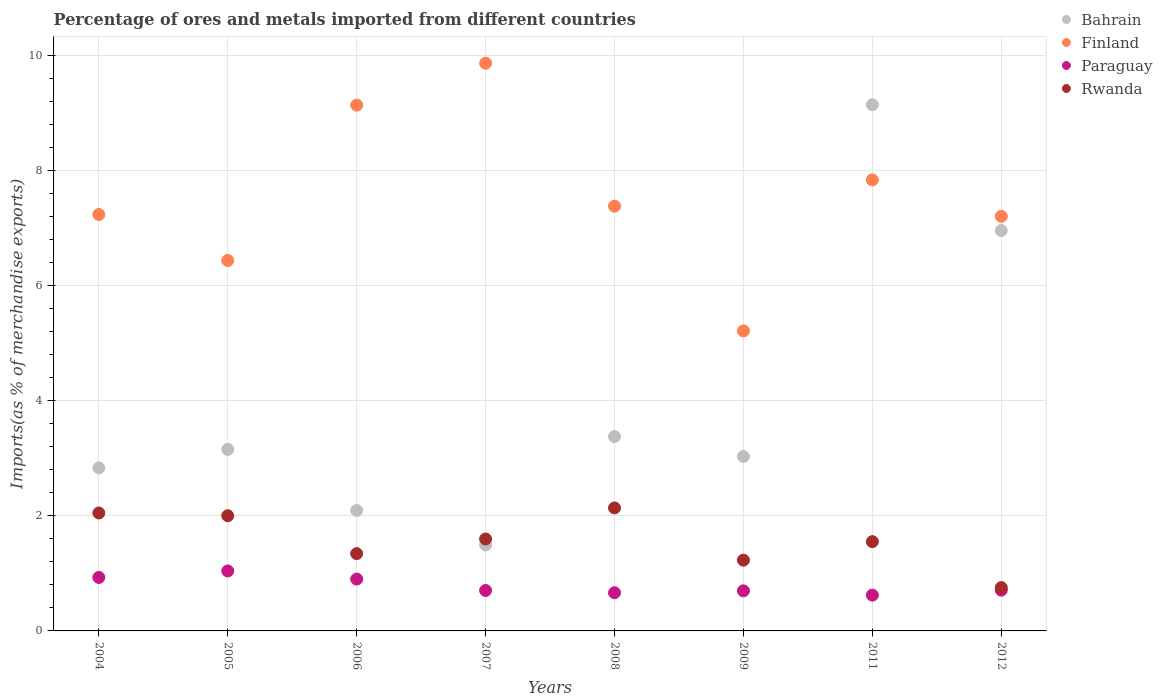What is the percentage of imports to different countries in Bahrain in 2011?
Make the answer very short. 9.14. Across all years, what is the maximum percentage of imports to different countries in Paraguay?
Provide a succinct answer. 1.04. Across all years, what is the minimum percentage of imports to different countries in Paraguay?
Your response must be concise. 0.62. In which year was the percentage of imports to different countries in Paraguay maximum?
Make the answer very short. 2005. In which year was the percentage of imports to different countries in Rwanda minimum?
Provide a short and direct response. 2012. What is the total percentage of imports to different countries in Bahrain in the graph?
Provide a succinct answer. 32.06. What is the difference between the percentage of imports to different countries in Bahrain in 2004 and that in 2012?
Your answer should be very brief. -4.12. What is the difference between the percentage of imports to different countries in Finland in 2006 and the percentage of imports to different countries in Rwanda in 2012?
Your answer should be very brief. 8.38. What is the average percentage of imports to different countries in Bahrain per year?
Your response must be concise. 4.01. In the year 2008, what is the difference between the percentage of imports to different countries in Paraguay and percentage of imports to different countries in Finland?
Your answer should be compact. -6.71. In how many years, is the percentage of imports to different countries in Rwanda greater than 4.4 %?
Offer a very short reply. 0. What is the ratio of the percentage of imports to different countries in Bahrain in 2009 to that in 2011?
Offer a very short reply. 0.33. What is the difference between the highest and the second highest percentage of imports to different countries in Rwanda?
Provide a succinct answer. 0.09. What is the difference between the highest and the lowest percentage of imports to different countries in Rwanda?
Offer a very short reply. 1.38. Is it the case that in every year, the sum of the percentage of imports to different countries in Paraguay and percentage of imports to different countries in Bahrain  is greater than the sum of percentage of imports to different countries in Finland and percentage of imports to different countries in Rwanda?
Make the answer very short. No. Is it the case that in every year, the sum of the percentage of imports to different countries in Paraguay and percentage of imports to different countries in Finland  is greater than the percentage of imports to different countries in Bahrain?
Your answer should be very brief. No. Is the percentage of imports to different countries in Rwanda strictly greater than the percentage of imports to different countries in Paraguay over the years?
Ensure brevity in your answer.  Yes. How many dotlines are there?
Ensure brevity in your answer.  4. How many years are there in the graph?
Make the answer very short. 8. Are the values on the major ticks of Y-axis written in scientific E-notation?
Offer a very short reply. No. Does the graph contain grids?
Ensure brevity in your answer.  Yes. Where does the legend appear in the graph?
Offer a terse response. Top right. What is the title of the graph?
Your answer should be compact. Percentage of ores and metals imported from different countries. What is the label or title of the X-axis?
Offer a very short reply. Years. What is the label or title of the Y-axis?
Give a very brief answer. Imports(as % of merchandise exports). What is the Imports(as % of merchandise exports) of Bahrain in 2004?
Give a very brief answer. 2.83. What is the Imports(as % of merchandise exports) in Finland in 2004?
Offer a very short reply. 7.23. What is the Imports(as % of merchandise exports) in Paraguay in 2004?
Your answer should be very brief. 0.93. What is the Imports(as % of merchandise exports) of Rwanda in 2004?
Offer a terse response. 2.05. What is the Imports(as % of merchandise exports) in Bahrain in 2005?
Provide a short and direct response. 3.15. What is the Imports(as % of merchandise exports) of Finland in 2005?
Provide a short and direct response. 6.43. What is the Imports(as % of merchandise exports) in Paraguay in 2005?
Offer a very short reply. 1.04. What is the Imports(as % of merchandise exports) in Rwanda in 2005?
Your response must be concise. 2. What is the Imports(as % of merchandise exports) of Bahrain in 2006?
Your answer should be very brief. 2.09. What is the Imports(as % of merchandise exports) of Finland in 2006?
Make the answer very short. 9.13. What is the Imports(as % of merchandise exports) of Paraguay in 2006?
Your answer should be compact. 0.9. What is the Imports(as % of merchandise exports) of Rwanda in 2006?
Your answer should be very brief. 1.34. What is the Imports(as % of merchandise exports) of Bahrain in 2007?
Provide a short and direct response. 1.49. What is the Imports(as % of merchandise exports) of Finland in 2007?
Your response must be concise. 9.86. What is the Imports(as % of merchandise exports) in Paraguay in 2007?
Provide a succinct answer. 0.7. What is the Imports(as % of merchandise exports) in Rwanda in 2007?
Your answer should be very brief. 1.6. What is the Imports(as % of merchandise exports) in Bahrain in 2008?
Keep it short and to the point. 3.37. What is the Imports(as % of merchandise exports) in Finland in 2008?
Your answer should be very brief. 7.38. What is the Imports(as % of merchandise exports) in Paraguay in 2008?
Make the answer very short. 0.66. What is the Imports(as % of merchandise exports) in Rwanda in 2008?
Provide a short and direct response. 2.14. What is the Imports(as % of merchandise exports) in Bahrain in 2009?
Ensure brevity in your answer.  3.03. What is the Imports(as % of merchandise exports) in Finland in 2009?
Your answer should be very brief. 5.21. What is the Imports(as % of merchandise exports) in Paraguay in 2009?
Your response must be concise. 0.7. What is the Imports(as % of merchandise exports) in Rwanda in 2009?
Provide a succinct answer. 1.23. What is the Imports(as % of merchandise exports) of Bahrain in 2011?
Give a very brief answer. 9.14. What is the Imports(as % of merchandise exports) in Finland in 2011?
Provide a succinct answer. 7.83. What is the Imports(as % of merchandise exports) in Paraguay in 2011?
Make the answer very short. 0.62. What is the Imports(as % of merchandise exports) of Rwanda in 2011?
Provide a short and direct response. 1.55. What is the Imports(as % of merchandise exports) of Bahrain in 2012?
Offer a very short reply. 6.95. What is the Imports(as % of merchandise exports) in Finland in 2012?
Keep it short and to the point. 7.2. What is the Imports(as % of merchandise exports) of Paraguay in 2012?
Offer a very short reply. 0.71. What is the Imports(as % of merchandise exports) of Rwanda in 2012?
Offer a very short reply. 0.75. Across all years, what is the maximum Imports(as % of merchandise exports) of Bahrain?
Provide a short and direct response. 9.14. Across all years, what is the maximum Imports(as % of merchandise exports) of Finland?
Offer a very short reply. 9.86. Across all years, what is the maximum Imports(as % of merchandise exports) of Paraguay?
Keep it short and to the point. 1.04. Across all years, what is the maximum Imports(as % of merchandise exports) in Rwanda?
Your response must be concise. 2.14. Across all years, what is the minimum Imports(as % of merchandise exports) of Bahrain?
Your response must be concise. 1.49. Across all years, what is the minimum Imports(as % of merchandise exports) of Finland?
Offer a terse response. 5.21. Across all years, what is the minimum Imports(as % of merchandise exports) in Paraguay?
Your answer should be very brief. 0.62. Across all years, what is the minimum Imports(as % of merchandise exports) of Rwanda?
Your answer should be very brief. 0.75. What is the total Imports(as % of merchandise exports) in Bahrain in the graph?
Ensure brevity in your answer.  32.06. What is the total Imports(as % of merchandise exports) in Finland in the graph?
Your answer should be compact. 60.27. What is the total Imports(as % of merchandise exports) of Paraguay in the graph?
Your response must be concise. 6.26. What is the total Imports(as % of merchandise exports) of Rwanda in the graph?
Offer a terse response. 12.66. What is the difference between the Imports(as % of merchandise exports) in Bahrain in 2004 and that in 2005?
Provide a short and direct response. -0.32. What is the difference between the Imports(as % of merchandise exports) in Finland in 2004 and that in 2005?
Provide a succinct answer. 0.8. What is the difference between the Imports(as % of merchandise exports) of Paraguay in 2004 and that in 2005?
Offer a very short reply. -0.11. What is the difference between the Imports(as % of merchandise exports) in Rwanda in 2004 and that in 2005?
Your answer should be very brief. 0.05. What is the difference between the Imports(as % of merchandise exports) of Bahrain in 2004 and that in 2006?
Keep it short and to the point. 0.74. What is the difference between the Imports(as % of merchandise exports) of Finland in 2004 and that in 2006?
Your response must be concise. -1.9. What is the difference between the Imports(as % of merchandise exports) of Paraguay in 2004 and that in 2006?
Your answer should be compact. 0.03. What is the difference between the Imports(as % of merchandise exports) of Rwanda in 2004 and that in 2006?
Your answer should be very brief. 0.71. What is the difference between the Imports(as % of merchandise exports) in Bahrain in 2004 and that in 2007?
Your answer should be compact. 1.34. What is the difference between the Imports(as % of merchandise exports) in Finland in 2004 and that in 2007?
Your response must be concise. -2.63. What is the difference between the Imports(as % of merchandise exports) of Paraguay in 2004 and that in 2007?
Offer a terse response. 0.23. What is the difference between the Imports(as % of merchandise exports) of Rwanda in 2004 and that in 2007?
Your answer should be compact. 0.45. What is the difference between the Imports(as % of merchandise exports) of Bahrain in 2004 and that in 2008?
Your response must be concise. -0.54. What is the difference between the Imports(as % of merchandise exports) of Finland in 2004 and that in 2008?
Your answer should be very brief. -0.14. What is the difference between the Imports(as % of merchandise exports) in Paraguay in 2004 and that in 2008?
Ensure brevity in your answer.  0.27. What is the difference between the Imports(as % of merchandise exports) in Rwanda in 2004 and that in 2008?
Ensure brevity in your answer.  -0.09. What is the difference between the Imports(as % of merchandise exports) in Bahrain in 2004 and that in 2009?
Give a very brief answer. -0.2. What is the difference between the Imports(as % of merchandise exports) in Finland in 2004 and that in 2009?
Keep it short and to the point. 2.02. What is the difference between the Imports(as % of merchandise exports) in Paraguay in 2004 and that in 2009?
Your response must be concise. 0.23. What is the difference between the Imports(as % of merchandise exports) of Rwanda in 2004 and that in 2009?
Keep it short and to the point. 0.82. What is the difference between the Imports(as % of merchandise exports) in Bahrain in 2004 and that in 2011?
Offer a terse response. -6.31. What is the difference between the Imports(as % of merchandise exports) of Finland in 2004 and that in 2011?
Your answer should be compact. -0.6. What is the difference between the Imports(as % of merchandise exports) in Paraguay in 2004 and that in 2011?
Keep it short and to the point. 0.31. What is the difference between the Imports(as % of merchandise exports) in Rwanda in 2004 and that in 2011?
Provide a succinct answer. 0.5. What is the difference between the Imports(as % of merchandise exports) of Bahrain in 2004 and that in 2012?
Make the answer very short. -4.12. What is the difference between the Imports(as % of merchandise exports) in Finland in 2004 and that in 2012?
Offer a very short reply. 0.03. What is the difference between the Imports(as % of merchandise exports) of Paraguay in 2004 and that in 2012?
Your answer should be compact. 0.22. What is the difference between the Imports(as % of merchandise exports) of Rwanda in 2004 and that in 2012?
Offer a terse response. 1.3. What is the difference between the Imports(as % of merchandise exports) of Bahrain in 2005 and that in 2006?
Keep it short and to the point. 1.06. What is the difference between the Imports(as % of merchandise exports) in Finland in 2005 and that in 2006?
Provide a short and direct response. -2.7. What is the difference between the Imports(as % of merchandise exports) in Paraguay in 2005 and that in 2006?
Ensure brevity in your answer.  0.14. What is the difference between the Imports(as % of merchandise exports) in Rwanda in 2005 and that in 2006?
Your answer should be very brief. 0.66. What is the difference between the Imports(as % of merchandise exports) of Bahrain in 2005 and that in 2007?
Provide a short and direct response. 1.66. What is the difference between the Imports(as % of merchandise exports) of Finland in 2005 and that in 2007?
Keep it short and to the point. -3.43. What is the difference between the Imports(as % of merchandise exports) of Paraguay in 2005 and that in 2007?
Your answer should be compact. 0.34. What is the difference between the Imports(as % of merchandise exports) of Rwanda in 2005 and that in 2007?
Give a very brief answer. 0.4. What is the difference between the Imports(as % of merchandise exports) of Bahrain in 2005 and that in 2008?
Your answer should be very brief. -0.22. What is the difference between the Imports(as % of merchandise exports) of Finland in 2005 and that in 2008?
Offer a very short reply. -0.94. What is the difference between the Imports(as % of merchandise exports) of Paraguay in 2005 and that in 2008?
Your response must be concise. 0.38. What is the difference between the Imports(as % of merchandise exports) of Rwanda in 2005 and that in 2008?
Your response must be concise. -0.14. What is the difference between the Imports(as % of merchandise exports) of Bahrain in 2005 and that in 2009?
Your response must be concise. 0.12. What is the difference between the Imports(as % of merchandise exports) in Finland in 2005 and that in 2009?
Keep it short and to the point. 1.22. What is the difference between the Imports(as % of merchandise exports) of Paraguay in 2005 and that in 2009?
Offer a very short reply. 0.34. What is the difference between the Imports(as % of merchandise exports) in Rwanda in 2005 and that in 2009?
Make the answer very short. 0.77. What is the difference between the Imports(as % of merchandise exports) of Bahrain in 2005 and that in 2011?
Make the answer very short. -5.99. What is the difference between the Imports(as % of merchandise exports) of Finland in 2005 and that in 2011?
Ensure brevity in your answer.  -1.4. What is the difference between the Imports(as % of merchandise exports) of Paraguay in 2005 and that in 2011?
Your answer should be compact. 0.42. What is the difference between the Imports(as % of merchandise exports) of Rwanda in 2005 and that in 2011?
Your answer should be very brief. 0.45. What is the difference between the Imports(as % of merchandise exports) in Bahrain in 2005 and that in 2012?
Offer a very short reply. -3.8. What is the difference between the Imports(as % of merchandise exports) of Finland in 2005 and that in 2012?
Make the answer very short. -0.77. What is the difference between the Imports(as % of merchandise exports) in Paraguay in 2005 and that in 2012?
Provide a succinct answer. 0.33. What is the difference between the Imports(as % of merchandise exports) of Rwanda in 2005 and that in 2012?
Provide a short and direct response. 1.25. What is the difference between the Imports(as % of merchandise exports) in Bahrain in 2006 and that in 2007?
Keep it short and to the point. 0.6. What is the difference between the Imports(as % of merchandise exports) in Finland in 2006 and that in 2007?
Your answer should be compact. -0.73. What is the difference between the Imports(as % of merchandise exports) in Paraguay in 2006 and that in 2007?
Offer a very short reply. 0.2. What is the difference between the Imports(as % of merchandise exports) of Rwanda in 2006 and that in 2007?
Offer a terse response. -0.25. What is the difference between the Imports(as % of merchandise exports) in Bahrain in 2006 and that in 2008?
Ensure brevity in your answer.  -1.28. What is the difference between the Imports(as % of merchandise exports) of Finland in 2006 and that in 2008?
Offer a terse response. 1.75. What is the difference between the Imports(as % of merchandise exports) in Paraguay in 2006 and that in 2008?
Your answer should be compact. 0.24. What is the difference between the Imports(as % of merchandise exports) in Rwanda in 2006 and that in 2008?
Give a very brief answer. -0.79. What is the difference between the Imports(as % of merchandise exports) of Bahrain in 2006 and that in 2009?
Your answer should be very brief. -0.94. What is the difference between the Imports(as % of merchandise exports) in Finland in 2006 and that in 2009?
Your answer should be compact. 3.92. What is the difference between the Imports(as % of merchandise exports) of Paraguay in 2006 and that in 2009?
Provide a succinct answer. 0.2. What is the difference between the Imports(as % of merchandise exports) in Rwanda in 2006 and that in 2009?
Your answer should be compact. 0.11. What is the difference between the Imports(as % of merchandise exports) of Bahrain in 2006 and that in 2011?
Offer a very short reply. -7.05. What is the difference between the Imports(as % of merchandise exports) of Finland in 2006 and that in 2011?
Make the answer very short. 1.3. What is the difference between the Imports(as % of merchandise exports) in Paraguay in 2006 and that in 2011?
Provide a short and direct response. 0.28. What is the difference between the Imports(as % of merchandise exports) in Rwanda in 2006 and that in 2011?
Give a very brief answer. -0.21. What is the difference between the Imports(as % of merchandise exports) of Bahrain in 2006 and that in 2012?
Your answer should be very brief. -4.86. What is the difference between the Imports(as % of merchandise exports) of Finland in 2006 and that in 2012?
Offer a terse response. 1.93. What is the difference between the Imports(as % of merchandise exports) in Paraguay in 2006 and that in 2012?
Your answer should be very brief. 0.19. What is the difference between the Imports(as % of merchandise exports) of Rwanda in 2006 and that in 2012?
Keep it short and to the point. 0.59. What is the difference between the Imports(as % of merchandise exports) of Bahrain in 2007 and that in 2008?
Make the answer very short. -1.88. What is the difference between the Imports(as % of merchandise exports) of Finland in 2007 and that in 2008?
Keep it short and to the point. 2.48. What is the difference between the Imports(as % of merchandise exports) in Paraguay in 2007 and that in 2008?
Your response must be concise. 0.04. What is the difference between the Imports(as % of merchandise exports) of Rwanda in 2007 and that in 2008?
Make the answer very short. -0.54. What is the difference between the Imports(as % of merchandise exports) of Bahrain in 2007 and that in 2009?
Your response must be concise. -1.54. What is the difference between the Imports(as % of merchandise exports) of Finland in 2007 and that in 2009?
Make the answer very short. 4.65. What is the difference between the Imports(as % of merchandise exports) in Paraguay in 2007 and that in 2009?
Make the answer very short. 0.01. What is the difference between the Imports(as % of merchandise exports) of Rwanda in 2007 and that in 2009?
Give a very brief answer. 0.37. What is the difference between the Imports(as % of merchandise exports) of Bahrain in 2007 and that in 2011?
Offer a terse response. -7.65. What is the difference between the Imports(as % of merchandise exports) in Finland in 2007 and that in 2011?
Your answer should be compact. 2.03. What is the difference between the Imports(as % of merchandise exports) of Paraguay in 2007 and that in 2011?
Provide a succinct answer. 0.08. What is the difference between the Imports(as % of merchandise exports) of Rwanda in 2007 and that in 2011?
Offer a very short reply. 0.05. What is the difference between the Imports(as % of merchandise exports) in Bahrain in 2007 and that in 2012?
Make the answer very short. -5.46. What is the difference between the Imports(as % of merchandise exports) of Finland in 2007 and that in 2012?
Provide a short and direct response. 2.66. What is the difference between the Imports(as % of merchandise exports) of Paraguay in 2007 and that in 2012?
Ensure brevity in your answer.  -0.01. What is the difference between the Imports(as % of merchandise exports) in Rwanda in 2007 and that in 2012?
Keep it short and to the point. 0.84. What is the difference between the Imports(as % of merchandise exports) in Bahrain in 2008 and that in 2009?
Offer a terse response. 0.34. What is the difference between the Imports(as % of merchandise exports) in Finland in 2008 and that in 2009?
Your answer should be very brief. 2.17. What is the difference between the Imports(as % of merchandise exports) of Paraguay in 2008 and that in 2009?
Your answer should be very brief. -0.03. What is the difference between the Imports(as % of merchandise exports) of Rwanda in 2008 and that in 2009?
Keep it short and to the point. 0.91. What is the difference between the Imports(as % of merchandise exports) of Bahrain in 2008 and that in 2011?
Provide a succinct answer. -5.76. What is the difference between the Imports(as % of merchandise exports) of Finland in 2008 and that in 2011?
Your answer should be compact. -0.46. What is the difference between the Imports(as % of merchandise exports) of Paraguay in 2008 and that in 2011?
Give a very brief answer. 0.04. What is the difference between the Imports(as % of merchandise exports) in Rwanda in 2008 and that in 2011?
Offer a very short reply. 0.59. What is the difference between the Imports(as % of merchandise exports) in Bahrain in 2008 and that in 2012?
Your answer should be compact. -3.58. What is the difference between the Imports(as % of merchandise exports) in Finland in 2008 and that in 2012?
Provide a succinct answer. 0.18. What is the difference between the Imports(as % of merchandise exports) in Paraguay in 2008 and that in 2012?
Give a very brief answer. -0.04. What is the difference between the Imports(as % of merchandise exports) in Rwanda in 2008 and that in 2012?
Ensure brevity in your answer.  1.38. What is the difference between the Imports(as % of merchandise exports) of Bahrain in 2009 and that in 2011?
Offer a very short reply. -6.11. What is the difference between the Imports(as % of merchandise exports) in Finland in 2009 and that in 2011?
Make the answer very short. -2.62. What is the difference between the Imports(as % of merchandise exports) in Paraguay in 2009 and that in 2011?
Provide a short and direct response. 0.07. What is the difference between the Imports(as % of merchandise exports) in Rwanda in 2009 and that in 2011?
Keep it short and to the point. -0.32. What is the difference between the Imports(as % of merchandise exports) of Bahrain in 2009 and that in 2012?
Your answer should be very brief. -3.92. What is the difference between the Imports(as % of merchandise exports) of Finland in 2009 and that in 2012?
Make the answer very short. -1.99. What is the difference between the Imports(as % of merchandise exports) of Paraguay in 2009 and that in 2012?
Ensure brevity in your answer.  -0.01. What is the difference between the Imports(as % of merchandise exports) in Rwanda in 2009 and that in 2012?
Your answer should be very brief. 0.48. What is the difference between the Imports(as % of merchandise exports) of Bahrain in 2011 and that in 2012?
Offer a terse response. 2.19. What is the difference between the Imports(as % of merchandise exports) of Finland in 2011 and that in 2012?
Offer a terse response. 0.63. What is the difference between the Imports(as % of merchandise exports) of Paraguay in 2011 and that in 2012?
Offer a terse response. -0.09. What is the difference between the Imports(as % of merchandise exports) in Rwanda in 2011 and that in 2012?
Offer a very short reply. 0.8. What is the difference between the Imports(as % of merchandise exports) in Bahrain in 2004 and the Imports(as % of merchandise exports) in Finland in 2005?
Your response must be concise. -3.6. What is the difference between the Imports(as % of merchandise exports) of Bahrain in 2004 and the Imports(as % of merchandise exports) of Paraguay in 2005?
Offer a terse response. 1.79. What is the difference between the Imports(as % of merchandise exports) of Bahrain in 2004 and the Imports(as % of merchandise exports) of Rwanda in 2005?
Keep it short and to the point. 0.83. What is the difference between the Imports(as % of merchandise exports) of Finland in 2004 and the Imports(as % of merchandise exports) of Paraguay in 2005?
Offer a terse response. 6.19. What is the difference between the Imports(as % of merchandise exports) in Finland in 2004 and the Imports(as % of merchandise exports) in Rwanda in 2005?
Provide a succinct answer. 5.23. What is the difference between the Imports(as % of merchandise exports) of Paraguay in 2004 and the Imports(as % of merchandise exports) of Rwanda in 2005?
Offer a very short reply. -1.07. What is the difference between the Imports(as % of merchandise exports) of Bahrain in 2004 and the Imports(as % of merchandise exports) of Finland in 2006?
Ensure brevity in your answer.  -6.3. What is the difference between the Imports(as % of merchandise exports) in Bahrain in 2004 and the Imports(as % of merchandise exports) in Paraguay in 2006?
Offer a very short reply. 1.93. What is the difference between the Imports(as % of merchandise exports) of Bahrain in 2004 and the Imports(as % of merchandise exports) of Rwanda in 2006?
Your answer should be very brief. 1.49. What is the difference between the Imports(as % of merchandise exports) in Finland in 2004 and the Imports(as % of merchandise exports) in Paraguay in 2006?
Ensure brevity in your answer.  6.33. What is the difference between the Imports(as % of merchandise exports) of Finland in 2004 and the Imports(as % of merchandise exports) of Rwanda in 2006?
Offer a terse response. 5.89. What is the difference between the Imports(as % of merchandise exports) in Paraguay in 2004 and the Imports(as % of merchandise exports) in Rwanda in 2006?
Your answer should be very brief. -0.41. What is the difference between the Imports(as % of merchandise exports) in Bahrain in 2004 and the Imports(as % of merchandise exports) in Finland in 2007?
Provide a succinct answer. -7.03. What is the difference between the Imports(as % of merchandise exports) of Bahrain in 2004 and the Imports(as % of merchandise exports) of Paraguay in 2007?
Your answer should be very brief. 2.13. What is the difference between the Imports(as % of merchandise exports) of Bahrain in 2004 and the Imports(as % of merchandise exports) of Rwanda in 2007?
Make the answer very short. 1.23. What is the difference between the Imports(as % of merchandise exports) of Finland in 2004 and the Imports(as % of merchandise exports) of Paraguay in 2007?
Offer a terse response. 6.53. What is the difference between the Imports(as % of merchandise exports) of Finland in 2004 and the Imports(as % of merchandise exports) of Rwanda in 2007?
Offer a very short reply. 5.64. What is the difference between the Imports(as % of merchandise exports) in Paraguay in 2004 and the Imports(as % of merchandise exports) in Rwanda in 2007?
Keep it short and to the point. -0.67. What is the difference between the Imports(as % of merchandise exports) of Bahrain in 2004 and the Imports(as % of merchandise exports) of Finland in 2008?
Provide a succinct answer. -4.55. What is the difference between the Imports(as % of merchandise exports) of Bahrain in 2004 and the Imports(as % of merchandise exports) of Paraguay in 2008?
Your response must be concise. 2.17. What is the difference between the Imports(as % of merchandise exports) of Bahrain in 2004 and the Imports(as % of merchandise exports) of Rwanda in 2008?
Offer a very short reply. 0.69. What is the difference between the Imports(as % of merchandise exports) of Finland in 2004 and the Imports(as % of merchandise exports) of Paraguay in 2008?
Your answer should be very brief. 6.57. What is the difference between the Imports(as % of merchandise exports) in Finland in 2004 and the Imports(as % of merchandise exports) in Rwanda in 2008?
Ensure brevity in your answer.  5.1. What is the difference between the Imports(as % of merchandise exports) in Paraguay in 2004 and the Imports(as % of merchandise exports) in Rwanda in 2008?
Keep it short and to the point. -1.21. What is the difference between the Imports(as % of merchandise exports) of Bahrain in 2004 and the Imports(as % of merchandise exports) of Finland in 2009?
Your answer should be very brief. -2.38. What is the difference between the Imports(as % of merchandise exports) in Bahrain in 2004 and the Imports(as % of merchandise exports) in Paraguay in 2009?
Your answer should be very brief. 2.13. What is the difference between the Imports(as % of merchandise exports) in Bahrain in 2004 and the Imports(as % of merchandise exports) in Rwanda in 2009?
Ensure brevity in your answer.  1.6. What is the difference between the Imports(as % of merchandise exports) in Finland in 2004 and the Imports(as % of merchandise exports) in Paraguay in 2009?
Provide a succinct answer. 6.54. What is the difference between the Imports(as % of merchandise exports) of Finland in 2004 and the Imports(as % of merchandise exports) of Rwanda in 2009?
Make the answer very short. 6. What is the difference between the Imports(as % of merchandise exports) of Paraguay in 2004 and the Imports(as % of merchandise exports) of Rwanda in 2009?
Your answer should be compact. -0.3. What is the difference between the Imports(as % of merchandise exports) of Bahrain in 2004 and the Imports(as % of merchandise exports) of Finland in 2011?
Your answer should be very brief. -5. What is the difference between the Imports(as % of merchandise exports) of Bahrain in 2004 and the Imports(as % of merchandise exports) of Paraguay in 2011?
Provide a succinct answer. 2.21. What is the difference between the Imports(as % of merchandise exports) in Bahrain in 2004 and the Imports(as % of merchandise exports) in Rwanda in 2011?
Provide a short and direct response. 1.28. What is the difference between the Imports(as % of merchandise exports) of Finland in 2004 and the Imports(as % of merchandise exports) of Paraguay in 2011?
Your answer should be very brief. 6.61. What is the difference between the Imports(as % of merchandise exports) in Finland in 2004 and the Imports(as % of merchandise exports) in Rwanda in 2011?
Provide a succinct answer. 5.68. What is the difference between the Imports(as % of merchandise exports) in Paraguay in 2004 and the Imports(as % of merchandise exports) in Rwanda in 2011?
Ensure brevity in your answer.  -0.62. What is the difference between the Imports(as % of merchandise exports) of Bahrain in 2004 and the Imports(as % of merchandise exports) of Finland in 2012?
Your answer should be compact. -4.37. What is the difference between the Imports(as % of merchandise exports) in Bahrain in 2004 and the Imports(as % of merchandise exports) in Paraguay in 2012?
Your answer should be very brief. 2.12. What is the difference between the Imports(as % of merchandise exports) in Bahrain in 2004 and the Imports(as % of merchandise exports) in Rwanda in 2012?
Give a very brief answer. 2.08. What is the difference between the Imports(as % of merchandise exports) in Finland in 2004 and the Imports(as % of merchandise exports) in Paraguay in 2012?
Offer a terse response. 6.52. What is the difference between the Imports(as % of merchandise exports) of Finland in 2004 and the Imports(as % of merchandise exports) of Rwanda in 2012?
Offer a terse response. 6.48. What is the difference between the Imports(as % of merchandise exports) in Paraguay in 2004 and the Imports(as % of merchandise exports) in Rwanda in 2012?
Ensure brevity in your answer.  0.18. What is the difference between the Imports(as % of merchandise exports) of Bahrain in 2005 and the Imports(as % of merchandise exports) of Finland in 2006?
Offer a very short reply. -5.98. What is the difference between the Imports(as % of merchandise exports) in Bahrain in 2005 and the Imports(as % of merchandise exports) in Paraguay in 2006?
Offer a terse response. 2.25. What is the difference between the Imports(as % of merchandise exports) in Bahrain in 2005 and the Imports(as % of merchandise exports) in Rwanda in 2006?
Your response must be concise. 1.81. What is the difference between the Imports(as % of merchandise exports) in Finland in 2005 and the Imports(as % of merchandise exports) in Paraguay in 2006?
Provide a short and direct response. 5.53. What is the difference between the Imports(as % of merchandise exports) of Finland in 2005 and the Imports(as % of merchandise exports) of Rwanda in 2006?
Keep it short and to the point. 5.09. What is the difference between the Imports(as % of merchandise exports) of Paraguay in 2005 and the Imports(as % of merchandise exports) of Rwanda in 2006?
Keep it short and to the point. -0.3. What is the difference between the Imports(as % of merchandise exports) of Bahrain in 2005 and the Imports(as % of merchandise exports) of Finland in 2007?
Your response must be concise. -6.71. What is the difference between the Imports(as % of merchandise exports) in Bahrain in 2005 and the Imports(as % of merchandise exports) in Paraguay in 2007?
Keep it short and to the point. 2.45. What is the difference between the Imports(as % of merchandise exports) in Bahrain in 2005 and the Imports(as % of merchandise exports) in Rwanda in 2007?
Make the answer very short. 1.56. What is the difference between the Imports(as % of merchandise exports) of Finland in 2005 and the Imports(as % of merchandise exports) of Paraguay in 2007?
Provide a succinct answer. 5.73. What is the difference between the Imports(as % of merchandise exports) in Finland in 2005 and the Imports(as % of merchandise exports) in Rwanda in 2007?
Your response must be concise. 4.84. What is the difference between the Imports(as % of merchandise exports) in Paraguay in 2005 and the Imports(as % of merchandise exports) in Rwanda in 2007?
Your answer should be very brief. -0.56. What is the difference between the Imports(as % of merchandise exports) in Bahrain in 2005 and the Imports(as % of merchandise exports) in Finland in 2008?
Your answer should be very brief. -4.22. What is the difference between the Imports(as % of merchandise exports) of Bahrain in 2005 and the Imports(as % of merchandise exports) of Paraguay in 2008?
Ensure brevity in your answer.  2.49. What is the difference between the Imports(as % of merchandise exports) of Bahrain in 2005 and the Imports(as % of merchandise exports) of Rwanda in 2008?
Ensure brevity in your answer.  1.02. What is the difference between the Imports(as % of merchandise exports) in Finland in 2005 and the Imports(as % of merchandise exports) in Paraguay in 2008?
Keep it short and to the point. 5.77. What is the difference between the Imports(as % of merchandise exports) of Finland in 2005 and the Imports(as % of merchandise exports) of Rwanda in 2008?
Your answer should be compact. 4.3. What is the difference between the Imports(as % of merchandise exports) of Paraguay in 2005 and the Imports(as % of merchandise exports) of Rwanda in 2008?
Make the answer very short. -1.09. What is the difference between the Imports(as % of merchandise exports) in Bahrain in 2005 and the Imports(as % of merchandise exports) in Finland in 2009?
Provide a succinct answer. -2.06. What is the difference between the Imports(as % of merchandise exports) of Bahrain in 2005 and the Imports(as % of merchandise exports) of Paraguay in 2009?
Give a very brief answer. 2.46. What is the difference between the Imports(as % of merchandise exports) in Bahrain in 2005 and the Imports(as % of merchandise exports) in Rwanda in 2009?
Your answer should be compact. 1.92. What is the difference between the Imports(as % of merchandise exports) of Finland in 2005 and the Imports(as % of merchandise exports) of Paraguay in 2009?
Your response must be concise. 5.74. What is the difference between the Imports(as % of merchandise exports) of Finland in 2005 and the Imports(as % of merchandise exports) of Rwanda in 2009?
Your response must be concise. 5.2. What is the difference between the Imports(as % of merchandise exports) of Paraguay in 2005 and the Imports(as % of merchandise exports) of Rwanda in 2009?
Ensure brevity in your answer.  -0.19. What is the difference between the Imports(as % of merchandise exports) in Bahrain in 2005 and the Imports(as % of merchandise exports) in Finland in 2011?
Your response must be concise. -4.68. What is the difference between the Imports(as % of merchandise exports) of Bahrain in 2005 and the Imports(as % of merchandise exports) of Paraguay in 2011?
Give a very brief answer. 2.53. What is the difference between the Imports(as % of merchandise exports) in Bahrain in 2005 and the Imports(as % of merchandise exports) in Rwanda in 2011?
Your response must be concise. 1.6. What is the difference between the Imports(as % of merchandise exports) in Finland in 2005 and the Imports(as % of merchandise exports) in Paraguay in 2011?
Provide a short and direct response. 5.81. What is the difference between the Imports(as % of merchandise exports) of Finland in 2005 and the Imports(as % of merchandise exports) of Rwanda in 2011?
Make the answer very short. 4.88. What is the difference between the Imports(as % of merchandise exports) in Paraguay in 2005 and the Imports(as % of merchandise exports) in Rwanda in 2011?
Your response must be concise. -0.51. What is the difference between the Imports(as % of merchandise exports) of Bahrain in 2005 and the Imports(as % of merchandise exports) of Finland in 2012?
Provide a short and direct response. -4.05. What is the difference between the Imports(as % of merchandise exports) in Bahrain in 2005 and the Imports(as % of merchandise exports) in Paraguay in 2012?
Offer a very short reply. 2.45. What is the difference between the Imports(as % of merchandise exports) in Bahrain in 2005 and the Imports(as % of merchandise exports) in Rwanda in 2012?
Your answer should be very brief. 2.4. What is the difference between the Imports(as % of merchandise exports) of Finland in 2005 and the Imports(as % of merchandise exports) of Paraguay in 2012?
Your response must be concise. 5.73. What is the difference between the Imports(as % of merchandise exports) in Finland in 2005 and the Imports(as % of merchandise exports) in Rwanda in 2012?
Give a very brief answer. 5.68. What is the difference between the Imports(as % of merchandise exports) of Paraguay in 2005 and the Imports(as % of merchandise exports) of Rwanda in 2012?
Your response must be concise. 0.29. What is the difference between the Imports(as % of merchandise exports) in Bahrain in 2006 and the Imports(as % of merchandise exports) in Finland in 2007?
Your answer should be very brief. -7.77. What is the difference between the Imports(as % of merchandise exports) of Bahrain in 2006 and the Imports(as % of merchandise exports) of Paraguay in 2007?
Your answer should be compact. 1.39. What is the difference between the Imports(as % of merchandise exports) of Bahrain in 2006 and the Imports(as % of merchandise exports) of Rwanda in 2007?
Your response must be concise. 0.5. What is the difference between the Imports(as % of merchandise exports) of Finland in 2006 and the Imports(as % of merchandise exports) of Paraguay in 2007?
Ensure brevity in your answer.  8.43. What is the difference between the Imports(as % of merchandise exports) of Finland in 2006 and the Imports(as % of merchandise exports) of Rwanda in 2007?
Make the answer very short. 7.53. What is the difference between the Imports(as % of merchandise exports) in Paraguay in 2006 and the Imports(as % of merchandise exports) in Rwanda in 2007?
Your response must be concise. -0.7. What is the difference between the Imports(as % of merchandise exports) of Bahrain in 2006 and the Imports(as % of merchandise exports) of Finland in 2008?
Offer a terse response. -5.28. What is the difference between the Imports(as % of merchandise exports) of Bahrain in 2006 and the Imports(as % of merchandise exports) of Paraguay in 2008?
Your answer should be very brief. 1.43. What is the difference between the Imports(as % of merchandise exports) of Bahrain in 2006 and the Imports(as % of merchandise exports) of Rwanda in 2008?
Provide a succinct answer. -0.04. What is the difference between the Imports(as % of merchandise exports) in Finland in 2006 and the Imports(as % of merchandise exports) in Paraguay in 2008?
Provide a succinct answer. 8.47. What is the difference between the Imports(as % of merchandise exports) in Finland in 2006 and the Imports(as % of merchandise exports) in Rwanda in 2008?
Offer a terse response. 7. What is the difference between the Imports(as % of merchandise exports) in Paraguay in 2006 and the Imports(as % of merchandise exports) in Rwanda in 2008?
Give a very brief answer. -1.24. What is the difference between the Imports(as % of merchandise exports) in Bahrain in 2006 and the Imports(as % of merchandise exports) in Finland in 2009?
Give a very brief answer. -3.12. What is the difference between the Imports(as % of merchandise exports) in Bahrain in 2006 and the Imports(as % of merchandise exports) in Paraguay in 2009?
Your answer should be compact. 1.4. What is the difference between the Imports(as % of merchandise exports) of Bahrain in 2006 and the Imports(as % of merchandise exports) of Rwanda in 2009?
Offer a very short reply. 0.86. What is the difference between the Imports(as % of merchandise exports) of Finland in 2006 and the Imports(as % of merchandise exports) of Paraguay in 2009?
Offer a very short reply. 8.43. What is the difference between the Imports(as % of merchandise exports) of Finland in 2006 and the Imports(as % of merchandise exports) of Rwanda in 2009?
Keep it short and to the point. 7.9. What is the difference between the Imports(as % of merchandise exports) of Paraguay in 2006 and the Imports(as % of merchandise exports) of Rwanda in 2009?
Your response must be concise. -0.33. What is the difference between the Imports(as % of merchandise exports) of Bahrain in 2006 and the Imports(as % of merchandise exports) of Finland in 2011?
Your answer should be compact. -5.74. What is the difference between the Imports(as % of merchandise exports) of Bahrain in 2006 and the Imports(as % of merchandise exports) of Paraguay in 2011?
Offer a terse response. 1.47. What is the difference between the Imports(as % of merchandise exports) of Bahrain in 2006 and the Imports(as % of merchandise exports) of Rwanda in 2011?
Provide a short and direct response. 0.54. What is the difference between the Imports(as % of merchandise exports) in Finland in 2006 and the Imports(as % of merchandise exports) in Paraguay in 2011?
Keep it short and to the point. 8.51. What is the difference between the Imports(as % of merchandise exports) of Finland in 2006 and the Imports(as % of merchandise exports) of Rwanda in 2011?
Your answer should be very brief. 7.58. What is the difference between the Imports(as % of merchandise exports) of Paraguay in 2006 and the Imports(as % of merchandise exports) of Rwanda in 2011?
Provide a succinct answer. -0.65. What is the difference between the Imports(as % of merchandise exports) in Bahrain in 2006 and the Imports(as % of merchandise exports) in Finland in 2012?
Provide a succinct answer. -5.11. What is the difference between the Imports(as % of merchandise exports) of Bahrain in 2006 and the Imports(as % of merchandise exports) of Paraguay in 2012?
Offer a very short reply. 1.38. What is the difference between the Imports(as % of merchandise exports) of Bahrain in 2006 and the Imports(as % of merchandise exports) of Rwanda in 2012?
Provide a succinct answer. 1.34. What is the difference between the Imports(as % of merchandise exports) in Finland in 2006 and the Imports(as % of merchandise exports) in Paraguay in 2012?
Your answer should be very brief. 8.42. What is the difference between the Imports(as % of merchandise exports) in Finland in 2006 and the Imports(as % of merchandise exports) in Rwanda in 2012?
Offer a very short reply. 8.38. What is the difference between the Imports(as % of merchandise exports) in Paraguay in 2006 and the Imports(as % of merchandise exports) in Rwanda in 2012?
Provide a succinct answer. 0.15. What is the difference between the Imports(as % of merchandise exports) of Bahrain in 2007 and the Imports(as % of merchandise exports) of Finland in 2008?
Your answer should be very brief. -5.88. What is the difference between the Imports(as % of merchandise exports) in Bahrain in 2007 and the Imports(as % of merchandise exports) in Paraguay in 2008?
Your answer should be compact. 0.83. What is the difference between the Imports(as % of merchandise exports) in Bahrain in 2007 and the Imports(as % of merchandise exports) in Rwanda in 2008?
Your answer should be very brief. -0.64. What is the difference between the Imports(as % of merchandise exports) in Finland in 2007 and the Imports(as % of merchandise exports) in Paraguay in 2008?
Keep it short and to the point. 9.2. What is the difference between the Imports(as % of merchandise exports) in Finland in 2007 and the Imports(as % of merchandise exports) in Rwanda in 2008?
Offer a terse response. 7.72. What is the difference between the Imports(as % of merchandise exports) of Paraguay in 2007 and the Imports(as % of merchandise exports) of Rwanda in 2008?
Your response must be concise. -1.43. What is the difference between the Imports(as % of merchandise exports) in Bahrain in 2007 and the Imports(as % of merchandise exports) in Finland in 2009?
Keep it short and to the point. -3.72. What is the difference between the Imports(as % of merchandise exports) of Bahrain in 2007 and the Imports(as % of merchandise exports) of Paraguay in 2009?
Your response must be concise. 0.8. What is the difference between the Imports(as % of merchandise exports) of Bahrain in 2007 and the Imports(as % of merchandise exports) of Rwanda in 2009?
Your answer should be compact. 0.26. What is the difference between the Imports(as % of merchandise exports) of Finland in 2007 and the Imports(as % of merchandise exports) of Paraguay in 2009?
Your response must be concise. 9.16. What is the difference between the Imports(as % of merchandise exports) in Finland in 2007 and the Imports(as % of merchandise exports) in Rwanda in 2009?
Provide a succinct answer. 8.63. What is the difference between the Imports(as % of merchandise exports) of Paraguay in 2007 and the Imports(as % of merchandise exports) of Rwanda in 2009?
Make the answer very short. -0.53. What is the difference between the Imports(as % of merchandise exports) in Bahrain in 2007 and the Imports(as % of merchandise exports) in Finland in 2011?
Provide a short and direct response. -6.34. What is the difference between the Imports(as % of merchandise exports) of Bahrain in 2007 and the Imports(as % of merchandise exports) of Paraguay in 2011?
Offer a very short reply. 0.87. What is the difference between the Imports(as % of merchandise exports) in Bahrain in 2007 and the Imports(as % of merchandise exports) in Rwanda in 2011?
Give a very brief answer. -0.06. What is the difference between the Imports(as % of merchandise exports) of Finland in 2007 and the Imports(as % of merchandise exports) of Paraguay in 2011?
Offer a terse response. 9.24. What is the difference between the Imports(as % of merchandise exports) of Finland in 2007 and the Imports(as % of merchandise exports) of Rwanda in 2011?
Make the answer very short. 8.31. What is the difference between the Imports(as % of merchandise exports) of Paraguay in 2007 and the Imports(as % of merchandise exports) of Rwanda in 2011?
Make the answer very short. -0.85. What is the difference between the Imports(as % of merchandise exports) of Bahrain in 2007 and the Imports(as % of merchandise exports) of Finland in 2012?
Keep it short and to the point. -5.71. What is the difference between the Imports(as % of merchandise exports) in Bahrain in 2007 and the Imports(as % of merchandise exports) in Paraguay in 2012?
Offer a terse response. 0.79. What is the difference between the Imports(as % of merchandise exports) of Bahrain in 2007 and the Imports(as % of merchandise exports) of Rwanda in 2012?
Give a very brief answer. 0.74. What is the difference between the Imports(as % of merchandise exports) of Finland in 2007 and the Imports(as % of merchandise exports) of Paraguay in 2012?
Give a very brief answer. 9.15. What is the difference between the Imports(as % of merchandise exports) of Finland in 2007 and the Imports(as % of merchandise exports) of Rwanda in 2012?
Keep it short and to the point. 9.11. What is the difference between the Imports(as % of merchandise exports) in Paraguay in 2007 and the Imports(as % of merchandise exports) in Rwanda in 2012?
Make the answer very short. -0.05. What is the difference between the Imports(as % of merchandise exports) of Bahrain in 2008 and the Imports(as % of merchandise exports) of Finland in 2009?
Offer a very short reply. -1.84. What is the difference between the Imports(as % of merchandise exports) in Bahrain in 2008 and the Imports(as % of merchandise exports) in Paraguay in 2009?
Offer a very short reply. 2.68. What is the difference between the Imports(as % of merchandise exports) in Bahrain in 2008 and the Imports(as % of merchandise exports) in Rwanda in 2009?
Your answer should be very brief. 2.15. What is the difference between the Imports(as % of merchandise exports) of Finland in 2008 and the Imports(as % of merchandise exports) of Paraguay in 2009?
Your response must be concise. 6.68. What is the difference between the Imports(as % of merchandise exports) of Finland in 2008 and the Imports(as % of merchandise exports) of Rwanda in 2009?
Give a very brief answer. 6.15. What is the difference between the Imports(as % of merchandise exports) of Paraguay in 2008 and the Imports(as % of merchandise exports) of Rwanda in 2009?
Provide a succinct answer. -0.57. What is the difference between the Imports(as % of merchandise exports) in Bahrain in 2008 and the Imports(as % of merchandise exports) in Finland in 2011?
Provide a succinct answer. -4.46. What is the difference between the Imports(as % of merchandise exports) in Bahrain in 2008 and the Imports(as % of merchandise exports) in Paraguay in 2011?
Offer a terse response. 2.75. What is the difference between the Imports(as % of merchandise exports) of Bahrain in 2008 and the Imports(as % of merchandise exports) of Rwanda in 2011?
Provide a succinct answer. 1.82. What is the difference between the Imports(as % of merchandise exports) of Finland in 2008 and the Imports(as % of merchandise exports) of Paraguay in 2011?
Keep it short and to the point. 6.75. What is the difference between the Imports(as % of merchandise exports) of Finland in 2008 and the Imports(as % of merchandise exports) of Rwanda in 2011?
Your answer should be compact. 5.83. What is the difference between the Imports(as % of merchandise exports) in Paraguay in 2008 and the Imports(as % of merchandise exports) in Rwanda in 2011?
Your answer should be very brief. -0.89. What is the difference between the Imports(as % of merchandise exports) in Bahrain in 2008 and the Imports(as % of merchandise exports) in Finland in 2012?
Give a very brief answer. -3.83. What is the difference between the Imports(as % of merchandise exports) of Bahrain in 2008 and the Imports(as % of merchandise exports) of Paraguay in 2012?
Your response must be concise. 2.67. What is the difference between the Imports(as % of merchandise exports) in Bahrain in 2008 and the Imports(as % of merchandise exports) in Rwanda in 2012?
Make the answer very short. 2.62. What is the difference between the Imports(as % of merchandise exports) in Finland in 2008 and the Imports(as % of merchandise exports) in Paraguay in 2012?
Ensure brevity in your answer.  6.67. What is the difference between the Imports(as % of merchandise exports) in Finland in 2008 and the Imports(as % of merchandise exports) in Rwanda in 2012?
Give a very brief answer. 6.62. What is the difference between the Imports(as % of merchandise exports) of Paraguay in 2008 and the Imports(as % of merchandise exports) of Rwanda in 2012?
Your answer should be compact. -0.09. What is the difference between the Imports(as % of merchandise exports) of Bahrain in 2009 and the Imports(as % of merchandise exports) of Finland in 2011?
Offer a very short reply. -4.8. What is the difference between the Imports(as % of merchandise exports) in Bahrain in 2009 and the Imports(as % of merchandise exports) in Paraguay in 2011?
Provide a succinct answer. 2.41. What is the difference between the Imports(as % of merchandise exports) of Bahrain in 2009 and the Imports(as % of merchandise exports) of Rwanda in 2011?
Your response must be concise. 1.48. What is the difference between the Imports(as % of merchandise exports) of Finland in 2009 and the Imports(as % of merchandise exports) of Paraguay in 2011?
Ensure brevity in your answer.  4.59. What is the difference between the Imports(as % of merchandise exports) in Finland in 2009 and the Imports(as % of merchandise exports) in Rwanda in 2011?
Offer a terse response. 3.66. What is the difference between the Imports(as % of merchandise exports) of Paraguay in 2009 and the Imports(as % of merchandise exports) of Rwanda in 2011?
Your answer should be very brief. -0.85. What is the difference between the Imports(as % of merchandise exports) of Bahrain in 2009 and the Imports(as % of merchandise exports) of Finland in 2012?
Offer a terse response. -4.17. What is the difference between the Imports(as % of merchandise exports) in Bahrain in 2009 and the Imports(as % of merchandise exports) in Paraguay in 2012?
Make the answer very short. 2.32. What is the difference between the Imports(as % of merchandise exports) of Bahrain in 2009 and the Imports(as % of merchandise exports) of Rwanda in 2012?
Provide a succinct answer. 2.28. What is the difference between the Imports(as % of merchandise exports) of Finland in 2009 and the Imports(as % of merchandise exports) of Paraguay in 2012?
Keep it short and to the point. 4.5. What is the difference between the Imports(as % of merchandise exports) in Finland in 2009 and the Imports(as % of merchandise exports) in Rwanda in 2012?
Ensure brevity in your answer.  4.46. What is the difference between the Imports(as % of merchandise exports) of Paraguay in 2009 and the Imports(as % of merchandise exports) of Rwanda in 2012?
Provide a short and direct response. -0.06. What is the difference between the Imports(as % of merchandise exports) in Bahrain in 2011 and the Imports(as % of merchandise exports) in Finland in 2012?
Offer a very short reply. 1.94. What is the difference between the Imports(as % of merchandise exports) of Bahrain in 2011 and the Imports(as % of merchandise exports) of Paraguay in 2012?
Offer a terse response. 8.43. What is the difference between the Imports(as % of merchandise exports) of Bahrain in 2011 and the Imports(as % of merchandise exports) of Rwanda in 2012?
Make the answer very short. 8.39. What is the difference between the Imports(as % of merchandise exports) of Finland in 2011 and the Imports(as % of merchandise exports) of Paraguay in 2012?
Offer a very short reply. 7.12. What is the difference between the Imports(as % of merchandise exports) in Finland in 2011 and the Imports(as % of merchandise exports) in Rwanda in 2012?
Your response must be concise. 7.08. What is the difference between the Imports(as % of merchandise exports) of Paraguay in 2011 and the Imports(as % of merchandise exports) of Rwanda in 2012?
Give a very brief answer. -0.13. What is the average Imports(as % of merchandise exports) of Bahrain per year?
Your response must be concise. 4.01. What is the average Imports(as % of merchandise exports) of Finland per year?
Your answer should be compact. 7.53. What is the average Imports(as % of merchandise exports) in Paraguay per year?
Keep it short and to the point. 0.78. What is the average Imports(as % of merchandise exports) of Rwanda per year?
Give a very brief answer. 1.58. In the year 2004, what is the difference between the Imports(as % of merchandise exports) in Bahrain and Imports(as % of merchandise exports) in Finland?
Your answer should be very brief. -4.4. In the year 2004, what is the difference between the Imports(as % of merchandise exports) of Bahrain and Imports(as % of merchandise exports) of Paraguay?
Keep it short and to the point. 1.9. In the year 2004, what is the difference between the Imports(as % of merchandise exports) in Bahrain and Imports(as % of merchandise exports) in Rwanda?
Keep it short and to the point. 0.78. In the year 2004, what is the difference between the Imports(as % of merchandise exports) of Finland and Imports(as % of merchandise exports) of Paraguay?
Your response must be concise. 6.3. In the year 2004, what is the difference between the Imports(as % of merchandise exports) of Finland and Imports(as % of merchandise exports) of Rwanda?
Make the answer very short. 5.18. In the year 2004, what is the difference between the Imports(as % of merchandise exports) of Paraguay and Imports(as % of merchandise exports) of Rwanda?
Your answer should be compact. -1.12. In the year 2005, what is the difference between the Imports(as % of merchandise exports) in Bahrain and Imports(as % of merchandise exports) in Finland?
Provide a short and direct response. -3.28. In the year 2005, what is the difference between the Imports(as % of merchandise exports) of Bahrain and Imports(as % of merchandise exports) of Paraguay?
Offer a terse response. 2.11. In the year 2005, what is the difference between the Imports(as % of merchandise exports) of Bahrain and Imports(as % of merchandise exports) of Rwanda?
Keep it short and to the point. 1.15. In the year 2005, what is the difference between the Imports(as % of merchandise exports) in Finland and Imports(as % of merchandise exports) in Paraguay?
Ensure brevity in your answer.  5.39. In the year 2005, what is the difference between the Imports(as % of merchandise exports) in Finland and Imports(as % of merchandise exports) in Rwanda?
Your answer should be very brief. 4.43. In the year 2005, what is the difference between the Imports(as % of merchandise exports) of Paraguay and Imports(as % of merchandise exports) of Rwanda?
Provide a succinct answer. -0.96. In the year 2006, what is the difference between the Imports(as % of merchandise exports) in Bahrain and Imports(as % of merchandise exports) in Finland?
Provide a short and direct response. -7.04. In the year 2006, what is the difference between the Imports(as % of merchandise exports) in Bahrain and Imports(as % of merchandise exports) in Paraguay?
Offer a very short reply. 1.19. In the year 2006, what is the difference between the Imports(as % of merchandise exports) of Bahrain and Imports(as % of merchandise exports) of Rwanda?
Provide a succinct answer. 0.75. In the year 2006, what is the difference between the Imports(as % of merchandise exports) of Finland and Imports(as % of merchandise exports) of Paraguay?
Keep it short and to the point. 8.23. In the year 2006, what is the difference between the Imports(as % of merchandise exports) in Finland and Imports(as % of merchandise exports) in Rwanda?
Your answer should be very brief. 7.79. In the year 2006, what is the difference between the Imports(as % of merchandise exports) of Paraguay and Imports(as % of merchandise exports) of Rwanda?
Provide a succinct answer. -0.44. In the year 2007, what is the difference between the Imports(as % of merchandise exports) of Bahrain and Imports(as % of merchandise exports) of Finland?
Give a very brief answer. -8.37. In the year 2007, what is the difference between the Imports(as % of merchandise exports) of Bahrain and Imports(as % of merchandise exports) of Paraguay?
Give a very brief answer. 0.79. In the year 2007, what is the difference between the Imports(as % of merchandise exports) of Bahrain and Imports(as % of merchandise exports) of Rwanda?
Offer a terse response. -0.1. In the year 2007, what is the difference between the Imports(as % of merchandise exports) in Finland and Imports(as % of merchandise exports) in Paraguay?
Your answer should be very brief. 9.16. In the year 2007, what is the difference between the Imports(as % of merchandise exports) of Finland and Imports(as % of merchandise exports) of Rwanda?
Your response must be concise. 8.26. In the year 2007, what is the difference between the Imports(as % of merchandise exports) of Paraguay and Imports(as % of merchandise exports) of Rwanda?
Offer a very short reply. -0.89. In the year 2008, what is the difference between the Imports(as % of merchandise exports) of Bahrain and Imports(as % of merchandise exports) of Finland?
Provide a succinct answer. -4. In the year 2008, what is the difference between the Imports(as % of merchandise exports) of Bahrain and Imports(as % of merchandise exports) of Paraguay?
Your response must be concise. 2.71. In the year 2008, what is the difference between the Imports(as % of merchandise exports) in Bahrain and Imports(as % of merchandise exports) in Rwanda?
Your response must be concise. 1.24. In the year 2008, what is the difference between the Imports(as % of merchandise exports) of Finland and Imports(as % of merchandise exports) of Paraguay?
Make the answer very short. 6.71. In the year 2008, what is the difference between the Imports(as % of merchandise exports) in Finland and Imports(as % of merchandise exports) in Rwanda?
Provide a succinct answer. 5.24. In the year 2008, what is the difference between the Imports(as % of merchandise exports) in Paraguay and Imports(as % of merchandise exports) in Rwanda?
Keep it short and to the point. -1.47. In the year 2009, what is the difference between the Imports(as % of merchandise exports) in Bahrain and Imports(as % of merchandise exports) in Finland?
Provide a succinct answer. -2.18. In the year 2009, what is the difference between the Imports(as % of merchandise exports) in Bahrain and Imports(as % of merchandise exports) in Paraguay?
Offer a very short reply. 2.33. In the year 2009, what is the difference between the Imports(as % of merchandise exports) in Bahrain and Imports(as % of merchandise exports) in Rwanda?
Your answer should be very brief. 1.8. In the year 2009, what is the difference between the Imports(as % of merchandise exports) in Finland and Imports(as % of merchandise exports) in Paraguay?
Offer a very short reply. 4.51. In the year 2009, what is the difference between the Imports(as % of merchandise exports) of Finland and Imports(as % of merchandise exports) of Rwanda?
Provide a short and direct response. 3.98. In the year 2009, what is the difference between the Imports(as % of merchandise exports) of Paraguay and Imports(as % of merchandise exports) of Rwanda?
Your answer should be compact. -0.53. In the year 2011, what is the difference between the Imports(as % of merchandise exports) in Bahrain and Imports(as % of merchandise exports) in Finland?
Provide a succinct answer. 1.31. In the year 2011, what is the difference between the Imports(as % of merchandise exports) of Bahrain and Imports(as % of merchandise exports) of Paraguay?
Give a very brief answer. 8.52. In the year 2011, what is the difference between the Imports(as % of merchandise exports) in Bahrain and Imports(as % of merchandise exports) in Rwanda?
Your response must be concise. 7.59. In the year 2011, what is the difference between the Imports(as % of merchandise exports) of Finland and Imports(as % of merchandise exports) of Paraguay?
Ensure brevity in your answer.  7.21. In the year 2011, what is the difference between the Imports(as % of merchandise exports) of Finland and Imports(as % of merchandise exports) of Rwanda?
Your answer should be compact. 6.28. In the year 2011, what is the difference between the Imports(as % of merchandise exports) of Paraguay and Imports(as % of merchandise exports) of Rwanda?
Your answer should be very brief. -0.93. In the year 2012, what is the difference between the Imports(as % of merchandise exports) of Bahrain and Imports(as % of merchandise exports) of Finland?
Keep it short and to the point. -0.25. In the year 2012, what is the difference between the Imports(as % of merchandise exports) of Bahrain and Imports(as % of merchandise exports) of Paraguay?
Offer a very short reply. 6.25. In the year 2012, what is the difference between the Imports(as % of merchandise exports) of Bahrain and Imports(as % of merchandise exports) of Rwanda?
Provide a short and direct response. 6.2. In the year 2012, what is the difference between the Imports(as % of merchandise exports) in Finland and Imports(as % of merchandise exports) in Paraguay?
Make the answer very short. 6.49. In the year 2012, what is the difference between the Imports(as % of merchandise exports) of Finland and Imports(as % of merchandise exports) of Rwanda?
Keep it short and to the point. 6.45. In the year 2012, what is the difference between the Imports(as % of merchandise exports) in Paraguay and Imports(as % of merchandise exports) in Rwanda?
Offer a very short reply. -0.05. What is the ratio of the Imports(as % of merchandise exports) of Bahrain in 2004 to that in 2005?
Provide a short and direct response. 0.9. What is the ratio of the Imports(as % of merchandise exports) in Finland in 2004 to that in 2005?
Keep it short and to the point. 1.12. What is the ratio of the Imports(as % of merchandise exports) in Paraguay in 2004 to that in 2005?
Provide a short and direct response. 0.89. What is the ratio of the Imports(as % of merchandise exports) of Bahrain in 2004 to that in 2006?
Provide a short and direct response. 1.35. What is the ratio of the Imports(as % of merchandise exports) in Finland in 2004 to that in 2006?
Make the answer very short. 0.79. What is the ratio of the Imports(as % of merchandise exports) in Paraguay in 2004 to that in 2006?
Ensure brevity in your answer.  1.03. What is the ratio of the Imports(as % of merchandise exports) of Rwanda in 2004 to that in 2006?
Make the answer very short. 1.53. What is the ratio of the Imports(as % of merchandise exports) of Bahrain in 2004 to that in 2007?
Offer a terse response. 1.9. What is the ratio of the Imports(as % of merchandise exports) of Finland in 2004 to that in 2007?
Provide a succinct answer. 0.73. What is the ratio of the Imports(as % of merchandise exports) in Paraguay in 2004 to that in 2007?
Your response must be concise. 1.32. What is the ratio of the Imports(as % of merchandise exports) in Rwanda in 2004 to that in 2007?
Your answer should be very brief. 1.28. What is the ratio of the Imports(as % of merchandise exports) of Bahrain in 2004 to that in 2008?
Offer a terse response. 0.84. What is the ratio of the Imports(as % of merchandise exports) in Finland in 2004 to that in 2008?
Offer a terse response. 0.98. What is the ratio of the Imports(as % of merchandise exports) in Paraguay in 2004 to that in 2008?
Provide a succinct answer. 1.4. What is the ratio of the Imports(as % of merchandise exports) of Rwanda in 2004 to that in 2008?
Your answer should be compact. 0.96. What is the ratio of the Imports(as % of merchandise exports) in Bahrain in 2004 to that in 2009?
Ensure brevity in your answer.  0.93. What is the ratio of the Imports(as % of merchandise exports) in Finland in 2004 to that in 2009?
Offer a terse response. 1.39. What is the ratio of the Imports(as % of merchandise exports) in Paraguay in 2004 to that in 2009?
Ensure brevity in your answer.  1.33. What is the ratio of the Imports(as % of merchandise exports) in Rwanda in 2004 to that in 2009?
Ensure brevity in your answer.  1.67. What is the ratio of the Imports(as % of merchandise exports) in Bahrain in 2004 to that in 2011?
Your response must be concise. 0.31. What is the ratio of the Imports(as % of merchandise exports) in Finland in 2004 to that in 2011?
Your answer should be compact. 0.92. What is the ratio of the Imports(as % of merchandise exports) in Paraguay in 2004 to that in 2011?
Give a very brief answer. 1.49. What is the ratio of the Imports(as % of merchandise exports) in Rwanda in 2004 to that in 2011?
Ensure brevity in your answer.  1.32. What is the ratio of the Imports(as % of merchandise exports) in Bahrain in 2004 to that in 2012?
Provide a succinct answer. 0.41. What is the ratio of the Imports(as % of merchandise exports) in Paraguay in 2004 to that in 2012?
Your answer should be compact. 1.31. What is the ratio of the Imports(as % of merchandise exports) in Rwanda in 2004 to that in 2012?
Provide a short and direct response. 2.72. What is the ratio of the Imports(as % of merchandise exports) in Bahrain in 2005 to that in 2006?
Ensure brevity in your answer.  1.51. What is the ratio of the Imports(as % of merchandise exports) in Finland in 2005 to that in 2006?
Give a very brief answer. 0.7. What is the ratio of the Imports(as % of merchandise exports) in Paraguay in 2005 to that in 2006?
Provide a short and direct response. 1.16. What is the ratio of the Imports(as % of merchandise exports) in Rwanda in 2005 to that in 2006?
Offer a terse response. 1.49. What is the ratio of the Imports(as % of merchandise exports) in Bahrain in 2005 to that in 2007?
Offer a terse response. 2.11. What is the ratio of the Imports(as % of merchandise exports) of Finland in 2005 to that in 2007?
Give a very brief answer. 0.65. What is the ratio of the Imports(as % of merchandise exports) in Paraguay in 2005 to that in 2007?
Give a very brief answer. 1.48. What is the ratio of the Imports(as % of merchandise exports) of Rwanda in 2005 to that in 2007?
Make the answer very short. 1.25. What is the ratio of the Imports(as % of merchandise exports) in Bahrain in 2005 to that in 2008?
Give a very brief answer. 0.93. What is the ratio of the Imports(as % of merchandise exports) of Finland in 2005 to that in 2008?
Offer a terse response. 0.87. What is the ratio of the Imports(as % of merchandise exports) of Paraguay in 2005 to that in 2008?
Your answer should be compact. 1.57. What is the ratio of the Imports(as % of merchandise exports) of Rwanda in 2005 to that in 2008?
Offer a terse response. 0.94. What is the ratio of the Imports(as % of merchandise exports) of Bahrain in 2005 to that in 2009?
Offer a very short reply. 1.04. What is the ratio of the Imports(as % of merchandise exports) in Finland in 2005 to that in 2009?
Your response must be concise. 1.23. What is the ratio of the Imports(as % of merchandise exports) in Paraguay in 2005 to that in 2009?
Keep it short and to the point. 1.5. What is the ratio of the Imports(as % of merchandise exports) in Rwanda in 2005 to that in 2009?
Ensure brevity in your answer.  1.63. What is the ratio of the Imports(as % of merchandise exports) of Bahrain in 2005 to that in 2011?
Provide a short and direct response. 0.34. What is the ratio of the Imports(as % of merchandise exports) in Finland in 2005 to that in 2011?
Give a very brief answer. 0.82. What is the ratio of the Imports(as % of merchandise exports) of Paraguay in 2005 to that in 2011?
Keep it short and to the point. 1.67. What is the ratio of the Imports(as % of merchandise exports) in Rwanda in 2005 to that in 2011?
Provide a succinct answer. 1.29. What is the ratio of the Imports(as % of merchandise exports) in Bahrain in 2005 to that in 2012?
Your response must be concise. 0.45. What is the ratio of the Imports(as % of merchandise exports) of Finland in 2005 to that in 2012?
Your answer should be compact. 0.89. What is the ratio of the Imports(as % of merchandise exports) in Paraguay in 2005 to that in 2012?
Offer a terse response. 1.47. What is the ratio of the Imports(as % of merchandise exports) of Rwanda in 2005 to that in 2012?
Provide a short and direct response. 2.66. What is the ratio of the Imports(as % of merchandise exports) of Bahrain in 2006 to that in 2007?
Give a very brief answer. 1.4. What is the ratio of the Imports(as % of merchandise exports) of Finland in 2006 to that in 2007?
Keep it short and to the point. 0.93. What is the ratio of the Imports(as % of merchandise exports) of Paraguay in 2006 to that in 2007?
Provide a short and direct response. 1.28. What is the ratio of the Imports(as % of merchandise exports) in Rwanda in 2006 to that in 2007?
Ensure brevity in your answer.  0.84. What is the ratio of the Imports(as % of merchandise exports) of Bahrain in 2006 to that in 2008?
Your answer should be very brief. 0.62. What is the ratio of the Imports(as % of merchandise exports) in Finland in 2006 to that in 2008?
Offer a very short reply. 1.24. What is the ratio of the Imports(as % of merchandise exports) of Paraguay in 2006 to that in 2008?
Keep it short and to the point. 1.36. What is the ratio of the Imports(as % of merchandise exports) of Rwanda in 2006 to that in 2008?
Provide a short and direct response. 0.63. What is the ratio of the Imports(as % of merchandise exports) of Bahrain in 2006 to that in 2009?
Offer a terse response. 0.69. What is the ratio of the Imports(as % of merchandise exports) in Finland in 2006 to that in 2009?
Make the answer very short. 1.75. What is the ratio of the Imports(as % of merchandise exports) of Paraguay in 2006 to that in 2009?
Provide a short and direct response. 1.29. What is the ratio of the Imports(as % of merchandise exports) in Rwanda in 2006 to that in 2009?
Offer a very short reply. 1.09. What is the ratio of the Imports(as % of merchandise exports) of Bahrain in 2006 to that in 2011?
Make the answer very short. 0.23. What is the ratio of the Imports(as % of merchandise exports) in Finland in 2006 to that in 2011?
Provide a succinct answer. 1.17. What is the ratio of the Imports(as % of merchandise exports) in Paraguay in 2006 to that in 2011?
Offer a terse response. 1.45. What is the ratio of the Imports(as % of merchandise exports) in Rwanda in 2006 to that in 2011?
Ensure brevity in your answer.  0.87. What is the ratio of the Imports(as % of merchandise exports) of Bahrain in 2006 to that in 2012?
Your response must be concise. 0.3. What is the ratio of the Imports(as % of merchandise exports) in Finland in 2006 to that in 2012?
Ensure brevity in your answer.  1.27. What is the ratio of the Imports(as % of merchandise exports) in Paraguay in 2006 to that in 2012?
Your answer should be very brief. 1.27. What is the ratio of the Imports(as % of merchandise exports) of Rwanda in 2006 to that in 2012?
Your response must be concise. 1.78. What is the ratio of the Imports(as % of merchandise exports) in Bahrain in 2007 to that in 2008?
Keep it short and to the point. 0.44. What is the ratio of the Imports(as % of merchandise exports) of Finland in 2007 to that in 2008?
Provide a succinct answer. 1.34. What is the ratio of the Imports(as % of merchandise exports) in Paraguay in 2007 to that in 2008?
Ensure brevity in your answer.  1.06. What is the ratio of the Imports(as % of merchandise exports) in Rwanda in 2007 to that in 2008?
Offer a terse response. 0.75. What is the ratio of the Imports(as % of merchandise exports) of Bahrain in 2007 to that in 2009?
Your response must be concise. 0.49. What is the ratio of the Imports(as % of merchandise exports) of Finland in 2007 to that in 2009?
Your response must be concise. 1.89. What is the ratio of the Imports(as % of merchandise exports) in Paraguay in 2007 to that in 2009?
Keep it short and to the point. 1.01. What is the ratio of the Imports(as % of merchandise exports) in Rwanda in 2007 to that in 2009?
Your response must be concise. 1.3. What is the ratio of the Imports(as % of merchandise exports) in Bahrain in 2007 to that in 2011?
Your response must be concise. 0.16. What is the ratio of the Imports(as % of merchandise exports) in Finland in 2007 to that in 2011?
Keep it short and to the point. 1.26. What is the ratio of the Imports(as % of merchandise exports) of Paraguay in 2007 to that in 2011?
Provide a short and direct response. 1.13. What is the ratio of the Imports(as % of merchandise exports) of Rwanda in 2007 to that in 2011?
Give a very brief answer. 1.03. What is the ratio of the Imports(as % of merchandise exports) of Bahrain in 2007 to that in 2012?
Your answer should be compact. 0.21. What is the ratio of the Imports(as % of merchandise exports) of Finland in 2007 to that in 2012?
Your answer should be compact. 1.37. What is the ratio of the Imports(as % of merchandise exports) of Paraguay in 2007 to that in 2012?
Make the answer very short. 0.99. What is the ratio of the Imports(as % of merchandise exports) in Rwanda in 2007 to that in 2012?
Provide a short and direct response. 2.12. What is the ratio of the Imports(as % of merchandise exports) in Bahrain in 2008 to that in 2009?
Your answer should be compact. 1.11. What is the ratio of the Imports(as % of merchandise exports) in Finland in 2008 to that in 2009?
Your answer should be compact. 1.42. What is the ratio of the Imports(as % of merchandise exports) in Paraguay in 2008 to that in 2009?
Offer a very short reply. 0.95. What is the ratio of the Imports(as % of merchandise exports) of Rwanda in 2008 to that in 2009?
Offer a very short reply. 1.74. What is the ratio of the Imports(as % of merchandise exports) in Bahrain in 2008 to that in 2011?
Your answer should be very brief. 0.37. What is the ratio of the Imports(as % of merchandise exports) of Finland in 2008 to that in 2011?
Your response must be concise. 0.94. What is the ratio of the Imports(as % of merchandise exports) of Paraguay in 2008 to that in 2011?
Your response must be concise. 1.07. What is the ratio of the Imports(as % of merchandise exports) of Rwanda in 2008 to that in 2011?
Make the answer very short. 1.38. What is the ratio of the Imports(as % of merchandise exports) of Bahrain in 2008 to that in 2012?
Provide a succinct answer. 0.49. What is the ratio of the Imports(as % of merchandise exports) of Finland in 2008 to that in 2012?
Offer a very short reply. 1.02. What is the ratio of the Imports(as % of merchandise exports) of Paraguay in 2008 to that in 2012?
Your answer should be compact. 0.94. What is the ratio of the Imports(as % of merchandise exports) of Rwanda in 2008 to that in 2012?
Make the answer very short. 2.84. What is the ratio of the Imports(as % of merchandise exports) of Bahrain in 2009 to that in 2011?
Provide a succinct answer. 0.33. What is the ratio of the Imports(as % of merchandise exports) of Finland in 2009 to that in 2011?
Offer a terse response. 0.67. What is the ratio of the Imports(as % of merchandise exports) in Paraguay in 2009 to that in 2011?
Provide a succinct answer. 1.12. What is the ratio of the Imports(as % of merchandise exports) of Rwanda in 2009 to that in 2011?
Offer a very short reply. 0.79. What is the ratio of the Imports(as % of merchandise exports) of Bahrain in 2009 to that in 2012?
Ensure brevity in your answer.  0.44. What is the ratio of the Imports(as % of merchandise exports) in Finland in 2009 to that in 2012?
Provide a short and direct response. 0.72. What is the ratio of the Imports(as % of merchandise exports) of Paraguay in 2009 to that in 2012?
Offer a terse response. 0.98. What is the ratio of the Imports(as % of merchandise exports) in Rwanda in 2009 to that in 2012?
Keep it short and to the point. 1.63. What is the ratio of the Imports(as % of merchandise exports) of Bahrain in 2011 to that in 2012?
Your answer should be compact. 1.31. What is the ratio of the Imports(as % of merchandise exports) in Finland in 2011 to that in 2012?
Provide a short and direct response. 1.09. What is the ratio of the Imports(as % of merchandise exports) of Paraguay in 2011 to that in 2012?
Your answer should be compact. 0.88. What is the ratio of the Imports(as % of merchandise exports) of Rwanda in 2011 to that in 2012?
Provide a succinct answer. 2.06. What is the difference between the highest and the second highest Imports(as % of merchandise exports) in Bahrain?
Offer a terse response. 2.19. What is the difference between the highest and the second highest Imports(as % of merchandise exports) of Finland?
Offer a terse response. 0.73. What is the difference between the highest and the second highest Imports(as % of merchandise exports) in Paraguay?
Ensure brevity in your answer.  0.11. What is the difference between the highest and the second highest Imports(as % of merchandise exports) of Rwanda?
Your answer should be compact. 0.09. What is the difference between the highest and the lowest Imports(as % of merchandise exports) in Bahrain?
Provide a succinct answer. 7.65. What is the difference between the highest and the lowest Imports(as % of merchandise exports) of Finland?
Make the answer very short. 4.65. What is the difference between the highest and the lowest Imports(as % of merchandise exports) in Paraguay?
Provide a short and direct response. 0.42. What is the difference between the highest and the lowest Imports(as % of merchandise exports) of Rwanda?
Make the answer very short. 1.38. 